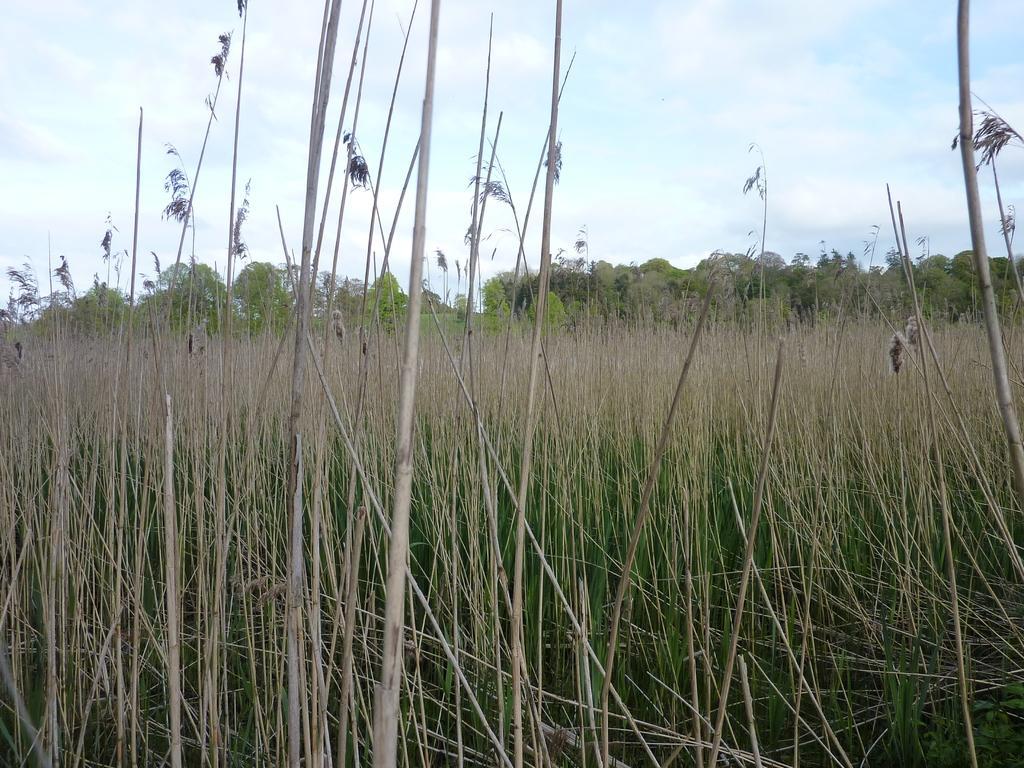How would you summarize this image in a sentence or two? In this image there is the sky towards the top of the image, there are clouds in the sky, there are trees, there are plants towards the bottom of the image. 